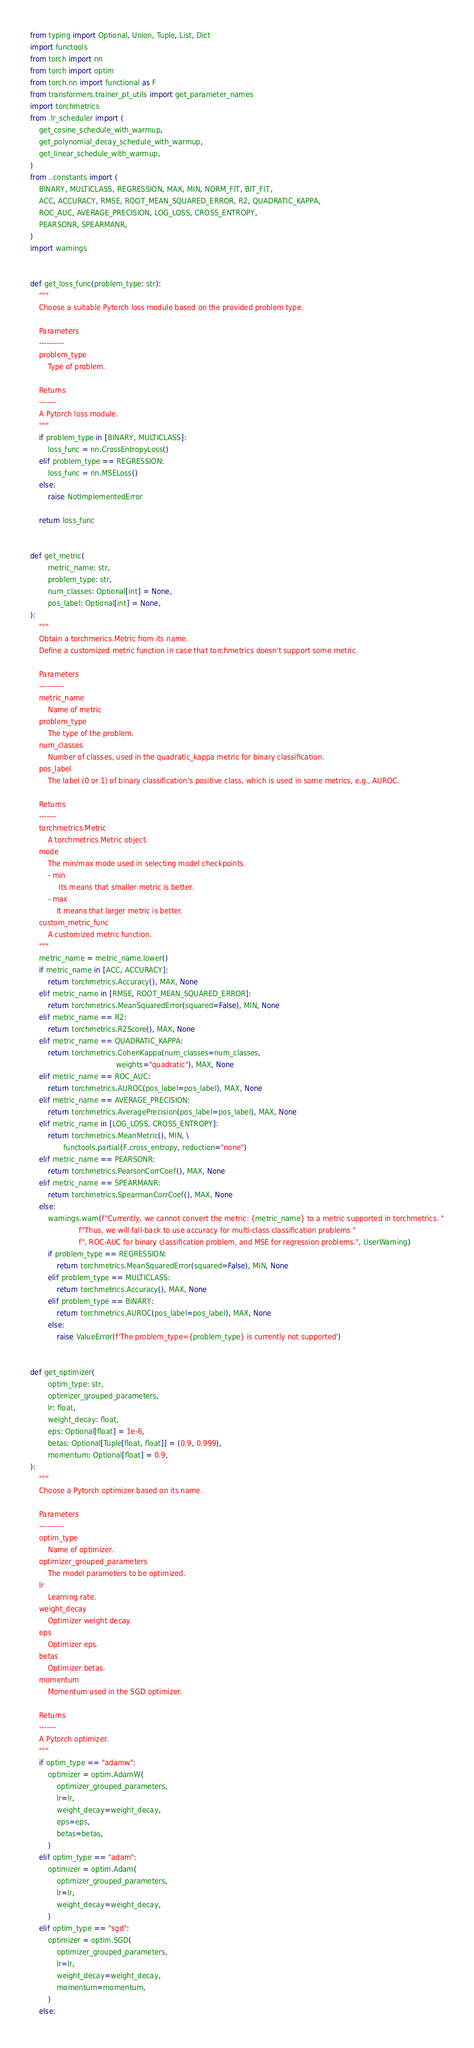<code> <loc_0><loc_0><loc_500><loc_500><_Python_>from typing import Optional, Union, Tuple, List, Dict
import functools
from torch import nn
from torch import optim
from torch.nn import functional as F
from transformers.trainer_pt_utils import get_parameter_names
import torchmetrics
from .lr_scheduler import (
    get_cosine_schedule_with_warmup,
    get_polynomial_decay_schedule_with_warmup,
    get_linear_schedule_with_warmup,
)
from ..constants import (
    BINARY, MULTICLASS, REGRESSION, MAX, MIN, NORM_FIT, BIT_FIT,
    ACC, ACCURACY, RMSE, ROOT_MEAN_SQUARED_ERROR, R2, QUADRATIC_KAPPA,
    ROC_AUC, AVERAGE_PRECISION, LOG_LOSS, CROSS_ENTROPY,
    PEARSONR, SPEARMANR,
)
import warnings


def get_loss_func(problem_type: str):
    """
    Choose a suitable Pytorch loss module based on the provided problem type.

    Parameters
    ----------
    problem_type
        Type of problem.

    Returns
    -------
    A Pytorch loss module.
    """
    if problem_type in [BINARY, MULTICLASS]:
        loss_func = nn.CrossEntropyLoss()
    elif problem_type == REGRESSION:
        loss_func = nn.MSELoss()
    else:
        raise NotImplementedError

    return loss_func


def get_metric(
        metric_name: str,
        problem_type: str,
        num_classes: Optional[int] = None,
        pos_label: Optional[int] = None,
):
    """
    Obtain a torchmerics.Metric from its name.
    Define a customized metric function in case that torchmetrics doesn't support some metric.

    Parameters
    ----------
    metric_name
        Name of metric
    problem_type
        The type of the problem.
    num_classes
        Number of classes, used in the quadratic_kappa metric for binary classification.
    pos_label
        The label (0 or 1) of binary classification's positive class, which is used in some metrics, e.g., AUROC.

    Returns
    -------
    torchmetrics.Metric
        A torchmetrics.Metric object.
    mode
        The min/max mode used in selecting model checkpoints.
        - min
             Its means that smaller metric is better.
        - max
            It means that larger metric is better.
    custom_metric_func
        A customized metric function.
    """
    metric_name = metric_name.lower()
    if metric_name in [ACC, ACCURACY]:
        return torchmetrics.Accuracy(), MAX, None
    elif metric_name in [RMSE, ROOT_MEAN_SQUARED_ERROR]:
        return torchmetrics.MeanSquaredError(squared=False), MIN, None
    elif metric_name == R2:
        return torchmetrics.R2Score(), MAX, None
    elif metric_name == QUADRATIC_KAPPA:
        return torchmetrics.CohenKappa(num_classes=num_classes,
                                       weights="quadratic"), MAX, None
    elif metric_name == ROC_AUC:
        return torchmetrics.AUROC(pos_label=pos_label), MAX, None
    elif metric_name == AVERAGE_PRECISION:
        return torchmetrics.AveragePrecision(pos_label=pos_label), MAX, None
    elif metric_name in [LOG_LOSS, CROSS_ENTROPY]:
        return torchmetrics.MeanMetric(), MIN, \
               functools.partial(F.cross_entropy, reduction="none")
    elif metric_name == PEARSONR:
        return torchmetrics.PearsonCorrCoef(), MAX, None
    elif metric_name == SPEARMANR:
        return torchmetrics.SpearmanCorrCoef(), MAX, None
    else:
        warnings.warn(f"Currently, we cannot convert the metric: {metric_name} to a metric supported in torchmetrics. "
                      f"Thus, we will fall-back to use accuracy for multi-class classification problems "
                      f", ROC-AUC for binary classification problem, and MSE for regression problems.", UserWarning)
        if problem_type == REGRESSION:
            return torchmetrics.MeanSquaredError(squared=False), MIN, None
        elif problem_type == MULTICLASS:
            return torchmetrics.Accuracy(), MAX, None
        elif problem_type == BINARY:
            return torchmetrics.AUROC(pos_label=pos_label), MAX, None
        else:
            raise ValueError(f'The problem_type={problem_type} is currently not supported')


def get_optimizer(
        optim_type: str,
        optimizer_grouped_parameters,
        lr: float,
        weight_decay: float,
        eps: Optional[float] = 1e-6,
        betas: Optional[Tuple[float, float]] = (0.9, 0.999),
        momentum: Optional[float] = 0.9,
):
    """
    Choose a Pytorch optimizer based on its name.

    Parameters
    ----------
    optim_type
        Name of optimizer.
    optimizer_grouped_parameters
        The model parameters to be optimized.
    lr
        Learning rate.
    weight_decay
        Optimizer weight decay.
    eps
        Optimizer eps.
    betas
        Optimizer betas.
    momentum
        Momentum used in the SGD optimizer.

    Returns
    -------
    A Pytorch optimizer.
    """
    if optim_type == "adamw":
        optimizer = optim.AdamW(
            optimizer_grouped_parameters,
            lr=lr,
            weight_decay=weight_decay,
            eps=eps,
            betas=betas,
        )
    elif optim_type == "adam":
        optimizer = optim.Adam(
            optimizer_grouped_parameters,
            lr=lr,
            weight_decay=weight_decay,
        )
    elif optim_type == "sgd":
        optimizer = optim.SGD(
            optimizer_grouped_parameters,
            lr=lr,
            weight_decay=weight_decay,
            momentum=momentum,
        )
    else:</code> 